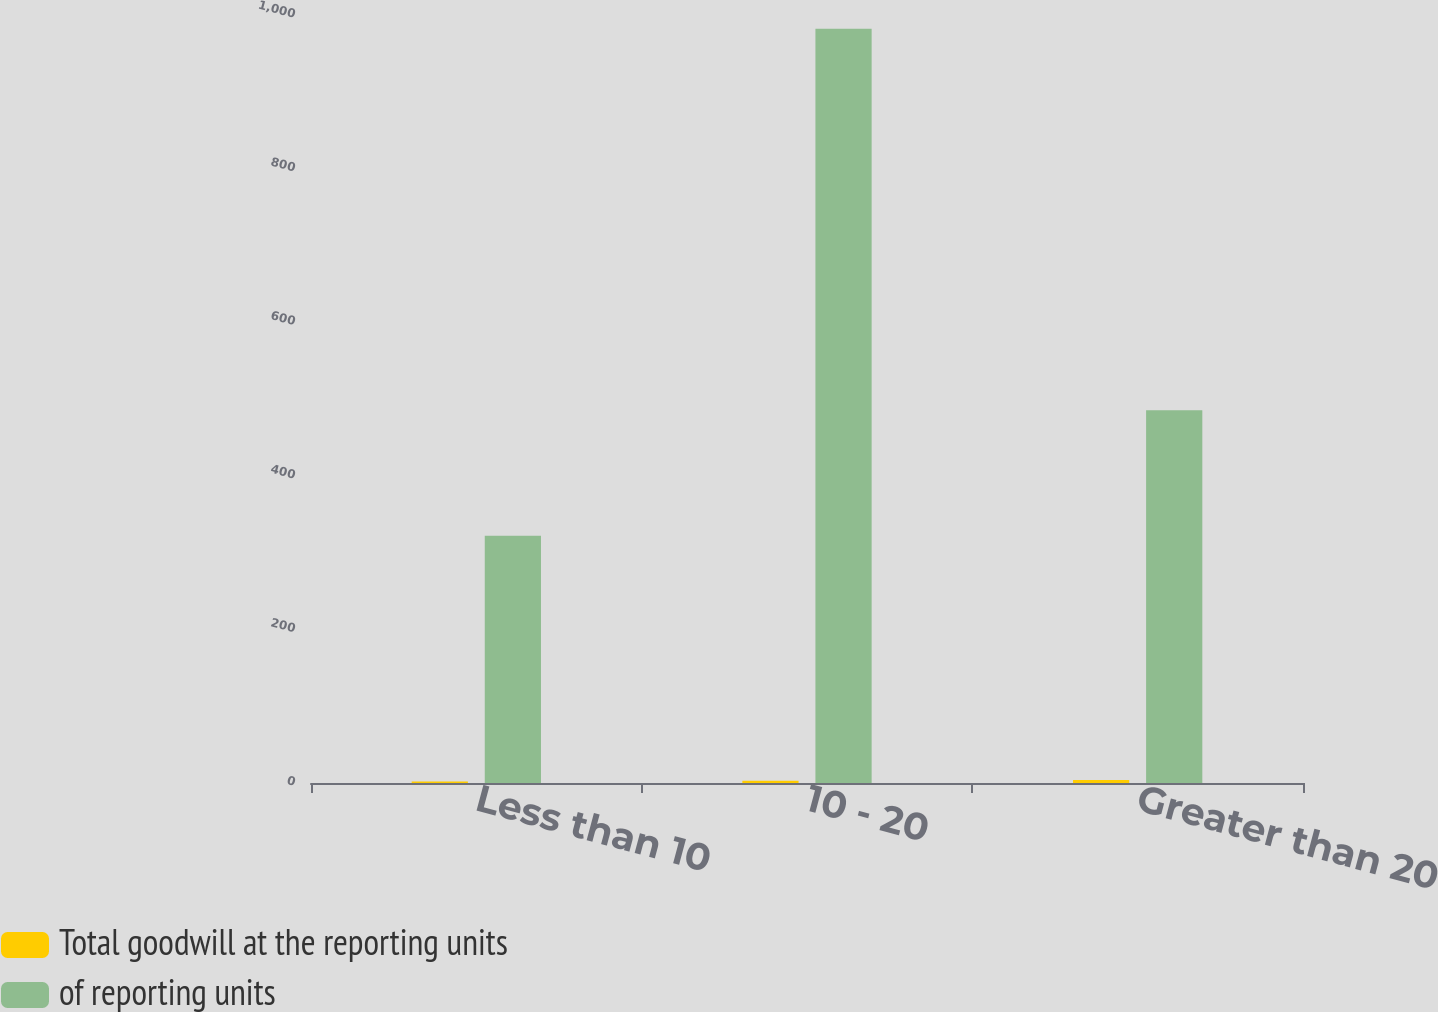Convert chart. <chart><loc_0><loc_0><loc_500><loc_500><stacked_bar_chart><ecel><fcel>Less than 10<fcel>10 - 20<fcel>Greater than 20<nl><fcel>Total goodwill at the reporting units<fcel>2<fcel>3<fcel>4<nl><fcel>of reporting units<fcel>321.9<fcel>982<fcel>485.4<nl></chart> 